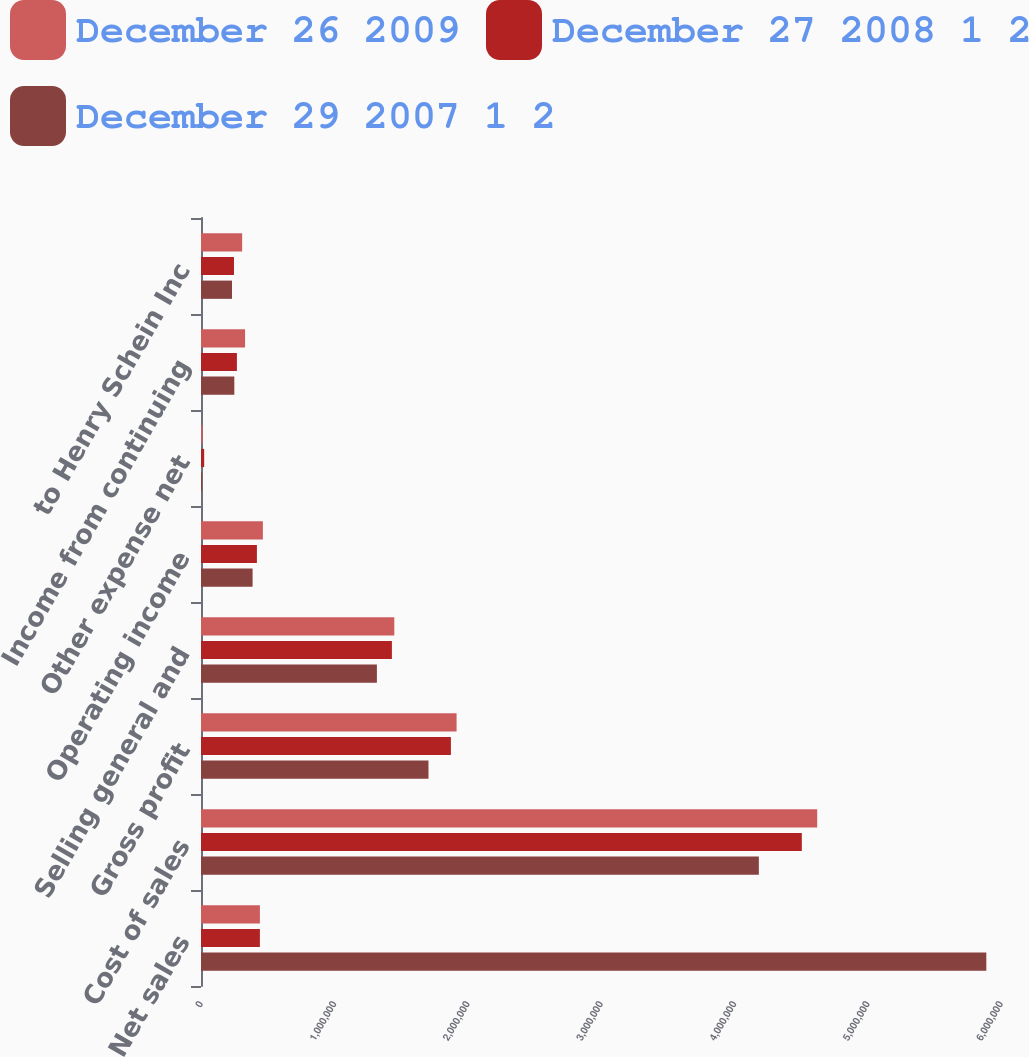Convert chart to OTSL. <chart><loc_0><loc_0><loc_500><loc_500><stacked_bar_chart><ecel><fcel>Net sales<fcel>Cost of sales<fcel>Gross profit<fcel>Selling general and<fcel>Operating income<fcel>Other expense net<fcel>Income from continuing<fcel>to Henry Schein Inc<nl><fcel>December 26 2009<fcel>441686<fcel>4.62152e+06<fcel>1.91682e+06<fcel>1.44972e+06<fcel>464085<fcel>11365<fcel>330442<fcel>308551<nl><fcel>December 27 2008 1 2<fcel>441686<fcel>4.50612e+06<fcel>1.8743e+06<fcel>1.43177e+06<fcel>419286<fcel>23837<fcel>269276<fcel>247347<nl><fcel>December 29 2007 1 2<fcel>5.88988e+06<fcel>4.18379e+06<fcel>1.70609e+06<fcel>1.31915e+06<fcel>386939<fcel>8430<fcel>249880<fcel>232529<nl></chart> 